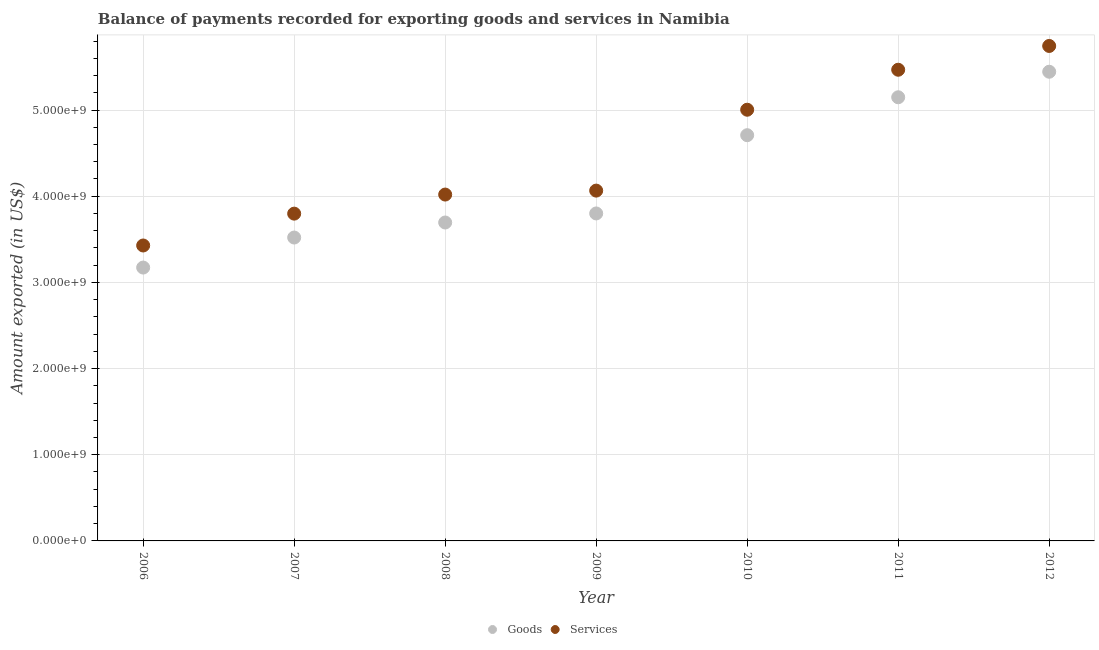Is the number of dotlines equal to the number of legend labels?
Your answer should be compact. Yes. What is the amount of services exported in 2008?
Your answer should be very brief. 4.02e+09. Across all years, what is the maximum amount of services exported?
Your answer should be compact. 5.74e+09. Across all years, what is the minimum amount of services exported?
Offer a terse response. 3.43e+09. In which year was the amount of goods exported maximum?
Offer a very short reply. 2012. What is the total amount of goods exported in the graph?
Provide a succinct answer. 2.95e+1. What is the difference between the amount of services exported in 2009 and that in 2012?
Provide a succinct answer. -1.68e+09. What is the difference between the amount of goods exported in 2006 and the amount of services exported in 2012?
Keep it short and to the point. -2.57e+09. What is the average amount of goods exported per year?
Ensure brevity in your answer.  4.21e+09. In the year 2007, what is the difference between the amount of goods exported and amount of services exported?
Provide a succinct answer. -2.77e+08. In how many years, is the amount of services exported greater than 4800000000 US$?
Your answer should be very brief. 3. What is the ratio of the amount of goods exported in 2008 to that in 2011?
Offer a terse response. 0.72. Is the amount of goods exported in 2007 less than that in 2009?
Give a very brief answer. Yes. Is the difference between the amount of services exported in 2010 and 2011 greater than the difference between the amount of goods exported in 2010 and 2011?
Your answer should be compact. No. What is the difference between the highest and the second highest amount of services exported?
Provide a succinct answer. 2.76e+08. What is the difference between the highest and the lowest amount of goods exported?
Make the answer very short. 2.27e+09. In how many years, is the amount of goods exported greater than the average amount of goods exported taken over all years?
Provide a succinct answer. 3. Is the sum of the amount of goods exported in 2010 and 2012 greater than the maximum amount of services exported across all years?
Offer a terse response. Yes. Does the amount of goods exported monotonically increase over the years?
Give a very brief answer. Yes. Is the amount of services exported strictly greater than the amount of goods exported over the years?
Keep it short and to the point. Yes. How many dotlines are there?
Offer a very short reply. 2. How many years are there in the graph?
Ensure brevity in your answer.  7. Does the graph contain grids?
Offer a terse response. Yes. Where does the legend appear in the graph?
Make the answer very short. Bottom center. How many legend labels are there?
Provide a succinct answer. 2. How are the legend labels stacked?
Make the answer very short. Horizontal. What is the title of the graph?
Provide a succinct answer. Balance of payments recorded for exporting goods and services in Namibia. Does "By country of asylum" appear as one of the legend labels in the graph?
Provide a short and direct response. No. What is the label or title of the X-axis?
Your response must be concise. Year. What is the label or title of the Y-axis?
Your answer should be very brief. Amount exported (in US$). What is the Amount exported (in US$) of Goods in 2006?
Ensure brevity in your answer.  3.17e+09. What is the Amount exported (in US$) of Services in 2006?
Make the answer very short. 3.43e+09. What is the Amount exported (in US$) of Goods in 2007?
Provide a short and direct response. 3.52e+09. What is the Amount exported (in US$) in Services in 2007?
Ensure brevity in your answer.  3.80e+09. What is the Amount exported (in US$) in Goods in 2008?
Offer a terse response. 3.70e+09. What is the Amount exported (in US$) in Services in 2008?
Make the answer very short. 4.02e+09. What is the Amount exported (in US$) in Goods in 2009?
Provide a succinct answer. 3.80e+09. What is the Amount exported (in US$) of Services in 2009?
Make the answer very short. 4.07e+09. What is the Amount exported (in US$) in Goods in 2010?
Make the answer very short. 4.71e+09. What is the Amount exported (in US$) of Services in 2010?
Keep it short and to the point. 5.00e+09. What is the Amount exported (in US$) of Goods in 2011?
Keep it short and to the point. 5.15e+09. What is the Amount exported (in US$) in Services in 2011?
Offer a very short reply. 5.47e+09. What is the Amount exported (in US$) of Goods in 2012?
Offer a terse response. 5.44e+09. What is the Amount exported (in US$) of Services in 2012?
Ensure brevity in your answer.  5.74e+09. Across all years, what is the maximum Amount exported (in US$) of Goods?
Ensure brevity in your answer.  5.44e+09. Across all years, what is the maximum Amount exported (in US$) in Services?
Give a very brief answer. 5.74e+09. Across all years, what is the minimum Amount exported (in US$) in Goods?
Offer a terse response. 3.17e+09. Across all years, what is the minimum Amount exported (in US$) of Services?
Your answer should be compact. 3.43e+09. What is the total Amount exported (in US$) in Goods in the graph?
Give a very brief answer. 2.95e+1. What is the total Amount exported (in US$) of Services in the graph?
Keep it short and to the point. 3.15e+1. What is the difference between the Amount exported (in US$) in Goods in 2006 and that in 2007?
Your answer should be very brief. -3.48e+08. What is the difference between the Amount exported (in US$) in Services in 2006 and that in 2007?
Make the answer very short. -3.70e+08. What is the difference between the Amount exported (in US$) in Goods in 2006 and that in 2008?
Ensure brevity in your answer.  -5.23e+08. What is the difference between the Amount exported (in US$) of Services in 2006 and that in 2008?
Offer a terse response. -5.91e+08. What is the difference between the Amount exported (in US$) of Goods in 2006 and that in 2009?
Offer a very short reply. -6.28e+08. What is the difference between the Amount exported (in US$) in Services in 2006 and that in 2009?
Ensure brevity in your answer.  -6.37e+08. What is the difference between the Amount exported (in US$) in Goods in 2006 and that in 2010?
Provide a short and direct response. -1.54e+09. What is the difference between the Amount exported (in US$) in Services in 2006 and that in 2010?
Ensure brevity in your answer.  -1.58e+09. What is the difference between the Amount exported (in US$) in Goods in 2006 and that in 2011?
Offer a very short reply. -1.98e+09. What is the difference between the Amount exported (in US$) of Services in 2006 and that in 2011?
Offer a terse response. -2.04e+09. What is the difference between the Amount exported (in US$) in Goods in 2006 and that in 2012?
Ensure brevity in your answer.  -2.27e+09. What is the difference between the Amount exported (in US$) in Services in 2006 and that in 2012?
Make the answer very short. -2.32e+09. What is the difference between the Amount exported (in US$) in Goods in 2007 and that in 2008?
Ensure brevity in your answer.  -1.74e+08. What is the difference between the Amount exported (in US$) of Services in 2007 and that in 2008?
Offer a very short reply. -2.21e+08. What is the difference between the Amount exported (in US$) in Goods in 2007 and that in 2009?
Make the answer very short. -2.79e+08. What is the difference between the Amount exported (in US$) of Services in 2007 and that in 2009?
Make the answer very short. -2.67e+08. What is the difference between the Amount exported (in US$) of Goods in 2007 and that in 2010?
Provide a succinct answer. -1.19e+09. What is the difference between the Amount exported (in US$) of Services in 2007 and that in 2010?
Your answer should be compact. -1.21e+09. What is the difference between the Amount exported (in US$) in Goods in 2007 and that in 2011?
Provide a short and direct response. -1.63e+09. What is the difference between the Amount exported (in US$) of Services in 2007 and that in 2011?
Provide a succinct answer. -1.67e+09. What is the difference between the Amount exported (in US$) of Goods in 2007 and that in 2012?
Your answer should be very brief. -1.92e+09. What is the difference between the Amount exported (in US$) of Services in 2007 and that in 2012?
Provide a succinct answer. -1.95e+09. What is the difference between the Amount exported (in US$) of Goods in 2008 and that in 2009?
Keep it short and to the point. -1.05e+08. What is the difference between the Amount exported (in US$) in Services in 2008 and that in 2009?
Give a very brief answer. -4.59e+07. What is the difference between the Amount exported (in US$) in Goods in 2008 and that in 2010?
Provide a succinct answer. -1.01e+09. What is the difference between the Amount exported (in US$) in Services in 2008 and that in 2010?
Your answer should be very brief. -9.84e+08. What is the difference between the Amount exported (in US$) in Goods in 2008 and that in 2011?
Your response must be concise. -1.45e+09. What is the difference between the Amount exported (in US$) of Services in 2008 and that in 2011?
Keep it short and to the point. -1.45e+09. What is the difference between the Amount exported (in US$) of Goods in 2008 and that in 2012?
Ensure brevity in your answer.  -1.75e+09. What is the difference between the Amount exported (in US$) of Services in 2008 and that in 2012?
Your response must be concise. -1.72e+09. What is the difference between the Amount exported (in US$) in Goods in 2009 and that in 2010?
Provide a succinct answer. -9.08e+08. What is the difference between the Amount exported (in US$) in Services in 2009 and that in 2010?
Provide a succinct answer. -9.39e+08. What is the difference between the Amount exported (in US$) in Goods in 2009 and that in 2011?
Your response must be concise. -1.35e+09. What is the difference between the Amount exported (in US$) of Services in 2009 and that in 2011?
Make the answer very short. -1.40e+09. What is the difference between the Amount exported (in US$) in Goods in 2009 and that in 2012?
Make the answer very short. -1.64e+09. What is the difference between the Amount exported (in US$) in Services in 2009 and that in 2012?
Your answer should be very brief. -1.68e+09. What is the difference between the Amount exported (in US$) of Goods in 2010 and that in 2011?
Make the answer very short. -4.40e+08. What is the difference between the Amount exported (in US$) in Services in 2010 and that in 2011?
Your answer should be compact. -4.64e+08. What is the difference between the Amount exported (in US$) of Goods in 2010 and that in 2012?
Your answer should be very brief. -7.36e+08. What is the difference between the Amount exported (in US$) in Services in 2010 and that in 2012?
Provide a short and direct response. -7.40e+08. What is the difference between the Amount exported (in US$) of Goods in 2011 and that in 2012?
Give a very brief answer. -2.96e+08. What is the difference between the Amount exported (in US$) of Services in 2011 and that in 2012?
Your answer should be compact. -2.76e+08. What is the difference between the Amount exported (in US$) in Goods in 2006 and the Amount exported (in US$) in Services in 2007?
Your answer should be compact. -6.26e+08. What is the difference between the Amount exported (in US$) of Goods in 2006 and the Amount exported (in US$) of Services in 2008?
Make the answer very short. -8.47e+08. What is the difference between the Amount exported (in US$) in Goods in 2006 and the Amount exported (in US$) in Services in 2009?
Offer a very short reply. -8.93e+08. What is the difference between the Amount exported (in US$) of Goods in 2006 and the Amount exported (in US$) of Services in 2010?
Ensure brevity in your answer.  -1.83e+09. What is the difference between the Amount exported (in US$) in Goods in 2006 and the Amount exported (in US$) in Services in 2011?
Your answer should be compact. -2.30e+09. What is the difference between the Amount exported (in US$) in Goods in 2006 and the Amount exported (in US$) in Services in 2012?
Make the answer very short. -2.57e+09. What is the difference between the Amount exported (in US$) in Goods in 2007 and the Amount exported (in US$) in Services in 2008?
Provide a succinct answer. -4.99e+08. What is the difference between the Amount exported (in US$) of Goods in 2007 and the Amount exported (in US$) of Services in 2009?
Provide a succinct answer. -5.44e+08. What is the difference between the Amount exported (in US$) of Goods in 2007 and the Amount exported (in US$) of Services in 2010?
Provide a short and direct response. -1.48e+09. What is the difference between the Amount exported (in US$) in Goods in 2007 and the Amount exported (in US$) in Services in 2011?
Offer a very short reply. -1.95e+09. What is the difference between the Amount exported (in US$) of Goods in 2007 and the Amount exported (in US$) of Services in 2012?
Your answer should be compact. -2.22e+09. What is the difference between the Amount exported (in US$) in Goods in 2008 and the Amount exported (in US$) in Services in 2009?
Ensure brevity in your answer.  -3.70e+08. What is the difference between the Amount exported (in US$) in Goods in 2008 and the Amount exported (in US$) in Services in 2010?
Provide a short and direct response. -1.31e+09. What is the difference between the Amount exported (in US$) in Goods in 2008 and the Amount exported (in US$) in Services in 2011?
Offer a terse response. -1.77e+09. What is the difference between the Amount exported (in US$) of Goods in 2008 and the Amount exported (in US$) of Services in 2012?
Provide a succinct answer. -2.05e+09. What is the difference between the Amount exported (in US$) of Goods in 2009 and the Amount exported (in US$) of Services in 2010?
Provide a succinct answer. -1.20e+09. What is the difference between the Amount exported (in US$) of Goods in 2009 and the Amount exported (in US$) of Services in 2011?
Give a very brief answer. -1.67e+09. What is the difference between the Amount exported (in US$) of Goods in 2009 and the Amount exported (in US$) of Services in 2012?
Make the answer very short. -1.94e+09. What is the difference between the Amount exported (in US$) in Goods in 2010 and the Amount exported (in US$) in Services in 2011?
Your answer should be very brief. -7.60e+08. What is the difference between the Amount exported (in US$) in Goods in 2010 and the Amount exported (in US$) in Services in 2012?
Give a very brief answer. -1.04e+09. What is the difference between the Amount exported (in US$) of Goods in 2011 and the Amount exported (in US$) of Services in 2012?
Provide a short and direct response. -5.95e+08. What is the average Amount exported (in US$) in Goods per year?
Your answer should be very brief. 4.21e+09. What is the average Amount exported (in US$) in Services per year?
Offer a very short reply. 4.50e+09. In the year 2006, what is the difference between the Amount exported (in US$) in Goods and Amount exported (in US$) in Services?
Provide a succinct answer. -2.56e+08. In the year 2007, what is the difference between the Amount exported (in US$) of Goods and Amount exported (in US$) of Services?
Keep it short and to the point. -2.77e+08. In the year 2008, what is the difference between the Amount exported (in US$) in Goods and Amount exported (in US$) in Services?
Ensure brevity in your answer.  -3.24e+08. In the year 2009, what is the difference between the Amount exported (in US$) of Goods and Amount exported (in US$) of Services?
Your response must be concise. -2.65e+08. In the year 2010, what is the difference between the Amount exported (in US$) in Goods and Amount exported (in US$) in Services?
Ensure brevity in your answer.  -2.96e+08. In the year 2011, what is the difference between the Amount exported (in US$) in Goods and Amount exported (in US$) in Services?
Offer a very short reply. -3.19e+08. In the year 2012, what is the difference between the Amount exported (in US$) of Goods and Amount exported (in US$) of Services?
Offer a very short reply. -2.99e+08. What is the ratio of the Amount exported (in US$) in Goods in 2006 to that in 2007?
Your answer should be very brief. 0.9. What is the ratio of the Amount exported (in US$) in Services in 2006 to that in 2007?
Your answer should be compact. 0.9. What is the ratio of the Amount exported (in US$) in Goods in 2006 to that in 2008?
Your answer should be very brief. 0.86. What is the ratio of the Amount exported (in US$) in Services in 2006 to that in 2008?
Offer a very short reply. 0.85. What is the ratio of the Amount exported (in US$) of Goods in 2006 to that in 2009?
Offer a terse response. 0.83. What is the ratio of the Amount exported (in US$) in Services in 2006 to that in 2009?
Give a very brief answer. 0.84. What is the ratio of the Amount exported (in US$) in Goods in 2006 to that in 2010?
Your answer should be compact. 0.67. What is the ratio of the Amount exported (in US$) in Services in 2006 to that in 2010?
Give a very brief answer. 0.69. What is the ratio of the Amount exported (in US$) in Goods in 2006 to that in 2011?
Keep it short and to the point. 0.62. What is the ratio of the Amount exported (in US$) in Services in 2006 to that in 2011?
Provide a short and direct response. 0.63. What is the ratio of the Amount exported (in US$) in Goods in 2006 to that in 2012?
Make the answer very short. 0.58. What is the ratio of the Amount exported (in US$) of Services in 2006 to that in 2012?
Provide a short and direct response. 0.6. What is the ratio of the Amount exported (in US$) of Goods in 2007 to that in 2008?
Give a very brief answer. 0.95. What is the ratio of the Amount exported (in US$) of Services in 2007 to that in 2008?
Make the answer very short. 0.94. What is the ratio of the Amount exported (in US$) in Goods in 2007 to that in 2009?
Your answer should be very brief. 0.93. What is the ratio of the Amount exported (in US$) of Services in 2007 to that in 2009?
Your answer should be very brief. 0.93. What is the ratio of the Amount exported (in US$) of Goods in 2007 to that in 2010?
Give a very brief answer. 0.75. What is the ratio of the Amount exported (in US$) of Services in 2007 to that in 2010?
Give a very brief answer. 0.76. What is the ratio of the Amount exported (in US$) of Goods in 2007 to that in 2011?
Give a very brief answer. 0.68. What is the ratio of the Amount exported (in US$) in Services in 2007 to that in 2011?
Provide a succinct answer. 0.69. What is the ratio of the Amount exported (in US$) of Goods in 2007 to that in 2012?
Offer a terse response. 0.65. What is the ratio of the Amount exported (in US$) in Services in 2007 to that in 2012?
Make the answer very short. 0.66. What is the ratio of the Amount exported (in US$) of Goods in 2008 to that in 2009?
Ensure brevity in your answer.  0.97. What is the ratio of the Amount exported (in US$) in Services in 2008 to that in 2009?
Ensure brevity in your answer.  0.99. What is the ratio of the Amount exported (in US$) of Goods in 2008 to that in 2010?
Keep it short and to the point. 0.78. What is the ratio of the Amount exported (in US$) in Services in 2008 to that in 2010?
Provide a short and direct response. 0.8. What is the ratio of the Amount exported (in US$) in Goods in 2008 to that in 2011?
Give a very brief answer. 0.72. What is the ratio of the Amount exported (in US$) of Services in 2008 to that in 2011?
Keep it short and to the point. 0.74. What is the ratio of the Amount exported (in US$) of Goods in 2008 to that in 2012?
Your answer should be compact. 0.68. What is the ratio of the Amount exported (in US$) of Services in 2008 to that in 2012?
Offer a terse response. 0.7. What is the ratio of the Amount exported (in US$) in Goods in 2009 to that in 2010?
Your answer should be very brief. 0.81. What is the ratio of the Amount exported (in US$) in Services in 2009 to that in 2010?
Your answer should be compact. 0.81. What is the ratio of the Amount exported (in US$) in Goods in 2009 to that in 2011?
Offer a terse response. 0.74. What is the ratio of the Amount exported (in US$) of Services in 2009 to that in 2011?
Your answer should be compact. 0.74. What is the ratio of the Amount exported (in US$) of Goods in 2009 to that in 2012?
Offer a very short reply. 0.7. What is the ratio of the Amount exported (in US$) in Services in 2009 to that in 2012?
Your response must be concise. 0.71. What is the ratio of the Amount exported (in US$) in Goods in 2010 to that in 2011?
Give a very brief answer. 0.91. What is the ratio of the Amount exported (in US$) in Services in 2010 to that in 2011?
Offer a very short reply. 0.92. What is the ratio of the Amount exported (in US$) in Goods in 2010 to that in 2012?
Ensure brevity in your answer.  0.86. What is the ratio of the Amount exported (in US$) in Services in 2010 to that in 2012?
Make the answer very short. 0.87. What is the ratio of the Amount exported (in US$) of Goods in 2011 to that in 2012?
Provide a short and direct response. 0.95. What is the ratio of the Amount exported (in US$) in Services in 2011 to that in 2012?
Your answer should be compact. 0.95. What is the difference between the highest and the second highest Amount exported (in US$) in Goods?
Offer a terse response. 2.96e+08. What is the difference between the highest and the second highest Amount exported (in US$) in Services?
Provide a short and direct response. 2.76e+08. What is the difference between the highest and the lowest Amount exported (in US$) in Goods?
Give a very brief answer. 2.27e+09. What is the difference between the highest and the lowest Amount exported (in US$) of Services?
Offer a terse response. 2.32e+09. 